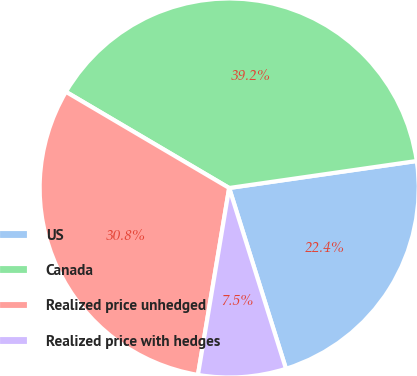<chart> <loc_0><loc_0><loc_500><loc_500><pie_chart><fcel>US<fcel>Canada<fcel>Realized price unhedged<fcel>Realized price with hedges<nl><fcel>22.43%<fcel>39.25%<fcel>30.84%<fcel>7.48%<nl></chart> 